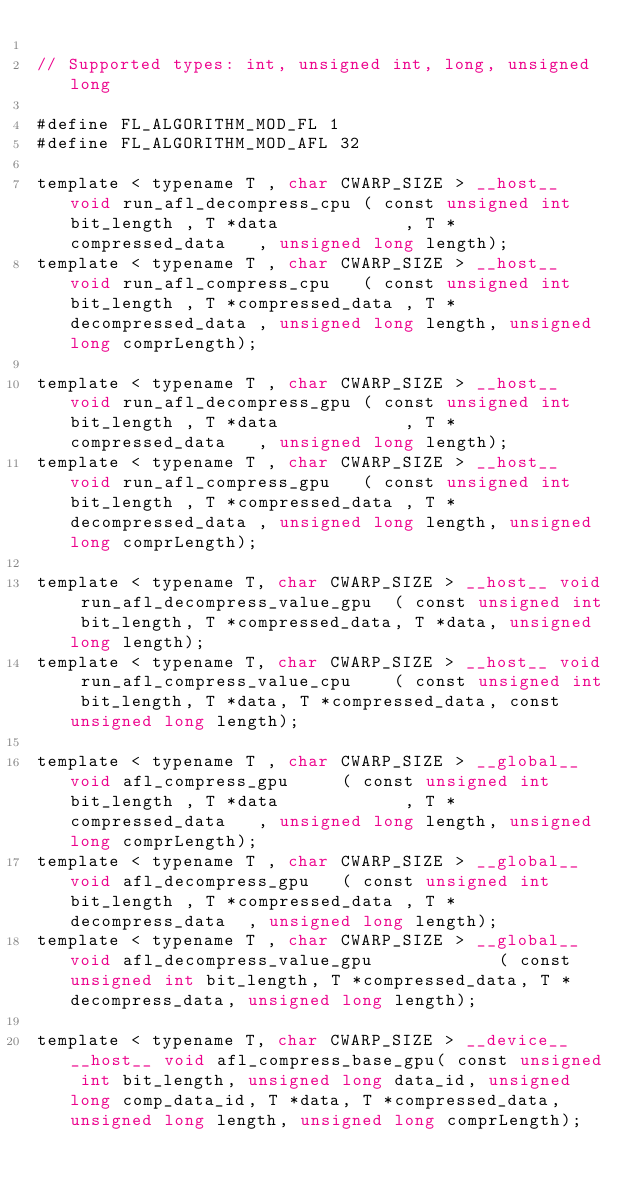<code> <loc_0><loc_0><loc_500><loc_500><_Cuda_>
// Supported types: int, unsigned int, long, unsigned long

#define FL_ALGORITHM_MOD_FL 1
#define FL_ALGORITHM_MOD_AFL 32 

template < typename T , char CWARP_SIZE > __host__ void run_afl_decompress_cpu ( const unsigned int bit_length , T *data            , T *compressed_data   , unsigned long length);
template < typename T , char CWARP_SIZE > __host__ void run_afl_compress_cpu   ( const unsigned int bit_length , T *compressed_data , T *decompressed_data , unsigned long length, unsigned long comprLength);

template < typename T , char CWARP_SIZE > __host__ void run_afl_decompress_gpu ( const unsigned int bit_length , T *data            , T *compressed_data   , unsigned long length);
template < typename T , char CWARP_SIZE > __host__ void run_afl_compress_gpu   ( const unsigned int bit_length , T *compressed_data , T *decompressed_data , unsigned long length, unsigned long comprLength);

template < typename T, char CWARP_SIZE > __host__ void run_afl_decompress_value_gpu  ( const unsigned int bit_length, T *compressed_data, T *data, unsigned long length);
template < typename T, char CWARP_SIZE > __host__ void run_afl_compress_value_cpu    ( const unsigned int bit_length, T *data, T *compressed_data, const unsigned long length);

template < typename T , char CWARP_SIZE > __global__ void afl_compress_gpu     ( const unsigned int bit_length , T *data            , T *compressed_data   , unsigned long length, unsigned long comprLength);
template < typename T , char CWARP_SIZE > __global__ void afl_decompress_gpu   ( const unsigned int bit_length , T *compressed_data , T * decompress_data  , unsigned long length);
template < typename T , char CWARP_SIZE > __global__ void afl_decompress_value_gpu            ( const unsigned int bit_length, T *compressed_data, T *decompress_data, unsigned long length);

template < typename T, char CWARP_SIZE > __device__ __host__ void afl_compress_base_gpu( const unsigned int bit_length, unsigned long data_id, unsigned long comp_data_id, T *data, T *compressed_data, unsigned long length, unsigned long comprLength);</code> 